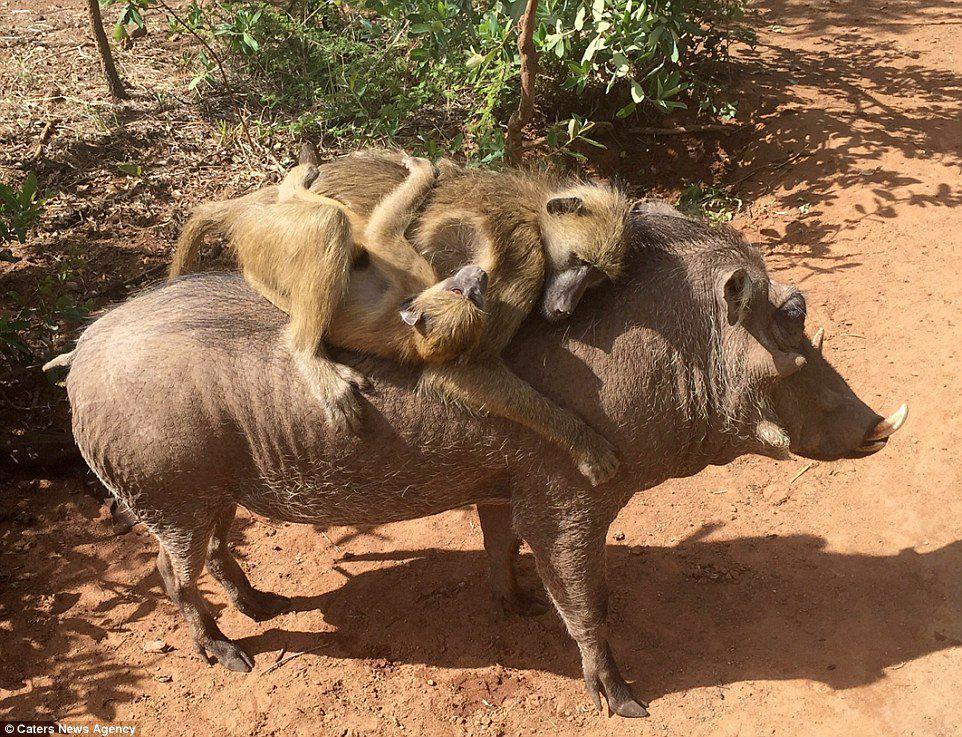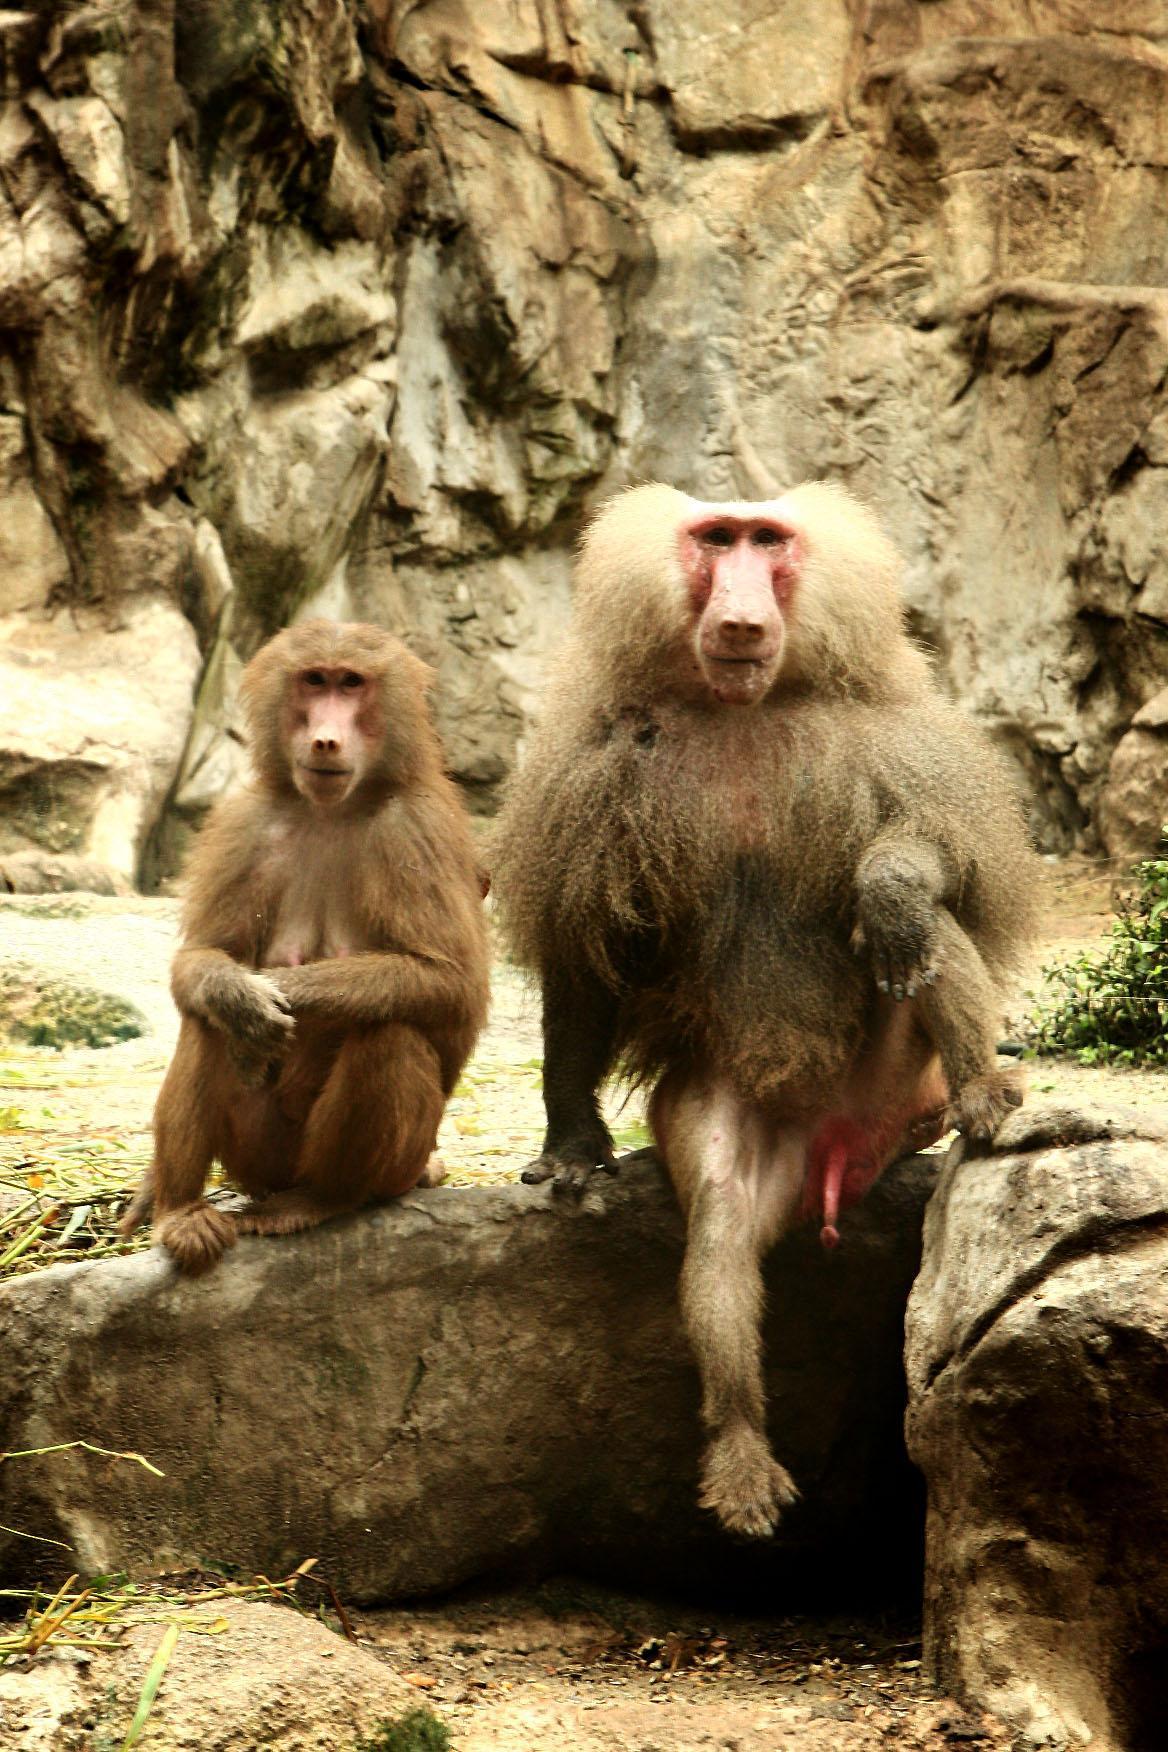The first image is the image on the left, the second image is the image on the right. Examine the images to the left and right. Is the description "At least one baboon is on the back of an animal bigger than itself, and no image contains more than two baboons." accurate? Answer yes or no. Yes. The first image is the image on the left, the second image is the image on the right. Examine the images to the left and right. Is the description "There are more primates in the image on the right." accurate? Answer yes or no. No. 